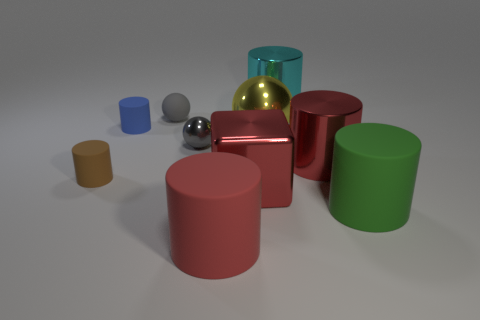How many objects are in the image and can you categorize them by color? There are ten objects in the image, categorized by color as follows: one red cube, one red cylinder, one green cylinder, one teal cylinder, one gold cylinder, one light blue cylinder, one brown cylinder, one gray sphere, and one silver sphere. Each object is reflective and has a distinct, simple geometric shape. 